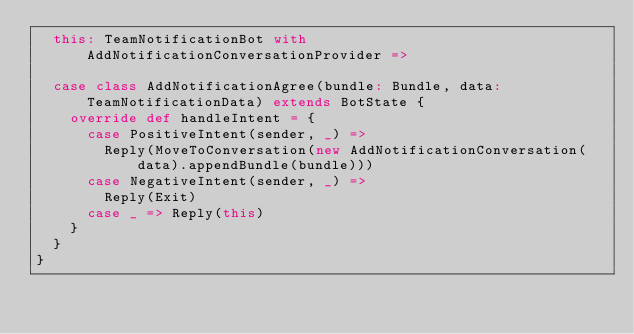Convert code to text. <code><loc_0><loc_0><loc_500><loc_500><_Scala_>  this: TeamNotificationBot with AddNotificationConversationProvider =>

  case class AddNotificationAgree(bundle: Bundle, data: TeamNotificationData) extends BotState {
    override def handleIntent = {
      case PositiveIntent(sender, _) =>
        Reply(MoveToConversation(new AddNotificationConversation(data).appendBundle(bundle)))
      case NegativeIntent(sender, _) =>
        Reply(Exit)
      case _ => Reply(this)
    }
  }
}
</code> 